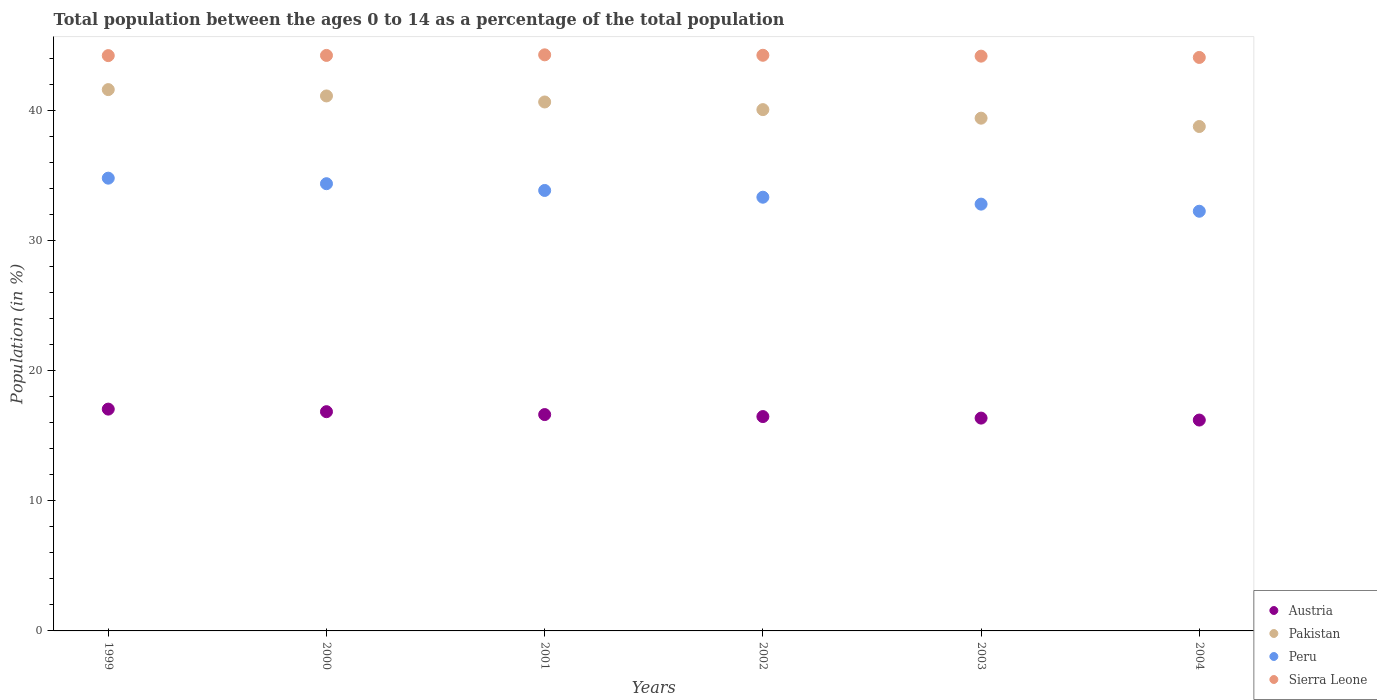Is the number of dotlines equal to the number of legend labels?
Provide a succinct answer. Yes. What is the percentage of the population ages 0 to 14 in Sierra Leone in 2001?
Provide a succinct answer. 44.25. Across all years, what is the maximum percentage of the population ages 0 to 14 in Pakistan?
Your answer should be compact. 41.58. Across all years, what is the minimum percentage of the population ages 0 to 14 in Sierra Leone?
Your response must be concise. 44.05. In which year was the percentage of the population ages 0 to 14 in Austria maximum?
Your answer should be compact. 1999. In which year was the percentage of the population ages 0 to 14 in Austria minimum?
Make the answer very short. 2004. What is the total percentage of the population ages 0 to 14 in Austria in the graph?
Your answer should be very brief. 99.51. What is the difference between the percentage of the population ages 0 to 14 in Austria in 2002 and that in 2004?
Your answer should be compact. 0.27. What is the difference between the percentage of the population ages 0 to 14 in Austria in 2002 and the percentage of the population ages 0 to 14 in Sierra Leone in 2001?
Your response must be concise. -27.79. What is the average percentage of the population ages 0 to 14 in Austria per year?
Provide a short and direct response. 16.59. In the year 1999, what is the difference between the percentage of the population ages 0 to 14 in Austria and percentage of the population ages 0 to 14 in Sierra Leone?
Ensure brevity in your answer.  -27.16. In how many years, is the percentage of the population ages 0 to 14 in Peru greater than 30?
Your response must be concise. 6. What is the ratio of the percentage of the population ages 0 to 14 in Austria in 2001 to that in 2003?
Provide a short and direct response. 1.02. What is the difference between the highest and the second highest percentage of the population ages 0 to 14 in Sierra Leone?
Ensure brevity in your answer.  0.03. What is the difference between the highest and the lowest percentage of the population ages 0 to 14 in Peru?
Offer a very short reply. 2.54. In how many years, is the percentage of the population ages 0 to 14 in Pakistan greater than the average percentage of the population ages 0 to 14 in Pakistan taken over all years?
Offer a very short reply. 3. Is the sum of the percentage of the population ages 0 to 14 in Pakistan in 2000 and 2004 greater than the maximum percentage of the population ages 0 to 14 in Peru across all years?
Provide a succinct answer. Yes. Is it the case that in every year, the sum of the percentage of the population ages 0 to 14 in Sierra Leone and percentage of the population ages 0 to 14 in Pakistan  is greater than the sum of percentage of the population ages 0 to 14 in Austria and percentage of the population ages 0 to 14 in Peru?
Provide a succinct answer. No. Does the percentage of the population ages 0 to 14 in Sierra Leone monotonically increase over the years?
Make the answer very short. No. Is the percentage of the population ages 0 to 14 in Sierra Leone strictly greater than the percentage of the population ages 0 to 14 in Austria over the years?
Keep it short and to the point. Yes. What is the difference between two consecutive major ticks on the Y-axis?
Provide a short and direct response. 10. Does the graph contain grids?
Keep it short and to the point. No. Where does the legend appear in the graph?
Offer a very short reply. Bottom right. How many legend labels are there?
Your response must be concise. 4. What is the title of the graph?
Your answer should be very brief. Total population between the ages 0 to 14 as a percentage of the total population. Does "Saudi Arabia" appear as one of the legend labels in the graph?
Offer a very short reply. No. What is the label or title of the X-axis?
Offer a very short reply. Years. What is the label or title of the Y-axis?
Provide a short and direct response. Population (in %). What is the Population (in %) in Austria in 1999?
Make the answer very short. 17.04. What is the Population (in %) of Pakistan in 1999?
Offer a terse response. 41.58. What is the Population (in %) of Peru in 1999?
Your answer should be very brief. 34.78. What is the Population (in %) of Sierra Leone in 1999?
Ensure brevity in your answer.  44.19. What is the Population (in %) of Austria in 2000?
Your answer should be compact. 16.84. What is the Population (in %) of Pakistan in 2000?
Your answer should be very brief. 41.1. What is the Population (in %) in Peru in 2000?
Offer a terse response. 34.35. What is the Population (in %) in Sierra Leone in 2000?
Offer a terse response. 44.21. What is the Population (in %) of Austria in 2001?
Offer a terse response. 16.62. What is the Population (in %) in Pakistan in 2001?
Your answer should be compact. 40.63. What is the Population (in %) in Peru in 2001?
Provide a short and direct response. 33.84. What is the Population (in %) in Sierra Leone in 2001?
Give a very brief answer. 44.25. What is the Population (in %) in Austria in 2002?
Give a very brief answer. 16.47. What is the Population (in %) in Pakistan in 2002?
Offer a terse response. 40.05. What is the Population (in %) of Peru in 2002?
Your answer should be very brief. 33.32. What is the Population (in %) in Sierra Leone in 2002?
Your answer should be compact. 44.22. What is the Population (in %) in Austria in 2003?
Keep it short and to the point. 16.35. What is the Population (in %) in Pakistan in 2003?
Your answer should be very brief. 39.39. What is the Population (in %) of Peru in 2003?
Keep it short and to the point. 32.79. What is the Population (in %) in Sierra Leone in 2003?
Give a very brief answer. 44.15. What is the Population (in %) of Austria in 2004?
Give a very brief answer. 16.2. What is the Population (in %) of Pakistan in 2004?
Give a very brief answer. 38.75. What is the Population (in %) in Peru in 2004?
Provide a short and direct response. 32.24. What is the Population (in %) in Sierra Leone in 2004?
Make the answer very short. 44.05. Across all years, what is the maximum Population (in %) of Austria?
Ensure brevity in your answer.  17.04. Across all years, what is the maximum Population (in %) of Pakistan?
Provide a succinct answer. 41.58. Across all years, what is the maximum Population (in %) of Peru?
Your answer should be compact. 34.78. Across all years, what is the maximum Population (in %) in Sierra Leone?
Make the answer very short. 44.25. Across all years, what is the minimum Population (in %) of Austria?
Provide a short and direct response. 16.2. Across all years, what is the minimum Population (in %) in Pakistan?
Your answer should be compact. 38.75. Across all years, what is the minimum Population (in %) of Peru?
Provide a succinct answer. 32.24. Across all years, what is the minimum Population (in %) in Sierra Leone?
Keep it short and to the point. 44.05. What is the total Population (in %) of Austria in the graph?
Make the answer very short. 99.51. What is the total Population (in %) in Pakistan in the graph?
Your answer should be very brief. 241.5. What is the total Population (in %) in Peru in the graph?
Keep it short and to the point. 201.31. What is the total Population (in %) in Sierra Leone in the graph?
Keep it short and to the point. 265.09. What is the difference between the Population (in %) in Austria in 1999 and that in 2000?
Provide a succinct answer. 0.2. What is the difference between the Population (in %) of Pakistan in 1999 and that in 2000?
Give a very brief answer. 0.49. What is the difference between the Population (in %) of Peru in 1999 and that in 2000?
Your answer should be compact. 0.43. What is the difference between the Population (in %) of Sierra Leone in 1999 and that in 2000?
Offer a very short reply. -0.01. What is the difference between the Population (in %) in Austria in 1999 and that in 2001?
Offer a terse response. 0.42. What is the difference between the Population (in %) of Pakistan in 1999 and that in 2001?
Offer a very short reply. 0.95. What is the difference between the Population (in %) of Peru in 1999 and that in 2001?
Ensure brevity in your answer.  0.94. What is the difference between the Population (in %) in Sierra Leone in 1999 and that in 2001?
Give a very brief answer. -0.06. What is the difference between the Population (in %) of Austria in 1999 and that in 2002?
Keep it short and to the point. 0.57. What is the difference between the Population (in %) in Pakistan in 1999 and that in 2002?
Ensure brevity in your answer.  1.54. What is the difference between the Population (in %) of Peru in 1999 and that in 2002?
Your answer should be very brief. 1.46. What is the difference between the Population (in %) of Sierra Leone in 1999 and that in 2002?
Provide a succinct answer. -0.03. What is the difference between the Population (in %) in Austria in 1999 and that in 2003?
Make the answer very short. 0.69. What is the difference between the Population (in %) of Pakistan in 1999 and that in 2003?
Provide a succinct answer. 2.19. What is the difference between the Population (in %) in Peru in 1999 and that in 2003?
Ensure brevity in your answer.  1.99. What is the difference between the Population (in %) in Sierra Leone in 1999 and that in 2003?
Your answer should be compact. 0.04. What is the difference between the Population (in %) in Austria in 1999 and that in 2004?
Make the answer very short. 0.84. What is the difference between the Population (in %) of Pakistan in 1999 and that in 2004?
Your answer should be compact. 2.83. What is the difference between the Population (in %) in Peru in 1999 and that in 2004?
Ensure brevity in your answer.  2.54. What is the difference between the Population (in %) in Sierra Leone in 1999 and that in 2004?
Ensure brevity in your answer.  0.14. What is the difference between the Population (in %) of Austria in 2000 and that in 2001?
Offer a terse response. 0.22. What is the difference between the Population (in %) of Pakistan in 2000 and that in 2001?
Ensure brevity in your answer.  0.46. What is the difference between the Population (in %) in Peru in 2000 and that in 2001?
Keep it short and to the point. 0.52. What is the difference between the Population (in %) of Sierra Leone in 2000 and that in 2001?
Your response must be concise. -0.04. What is the difference between the Population (in %) in Austria in 2000 and that in 2002?
Offer a terse response. 0.38. What is the difference between the Population (in %) of Pakistan in 2000 and that in 2002?
Your answer should be compact. 1.05. What is the difference between the Population (in %) in Peru in 2000 and that in 2002?
Ensure brevity in your answer.  1.04. What is the difference between the Population (in %) in Sierra Leone in 2000 and that in 2002?
Your response must be concise. -0.01. What is the difference between the Population (in %) in Austria in 2000 and that in 2003?
Ensure brevity in your answer.  0.49. What is the difference between the Population (in %) in Pakistan in 2000 and that in 2003?
Ensure brevity in your answer.  1.71. What is the difference between the Population (in %) in Peru in 2000 and that in 2003?
Offer a terse response. 1.57. What is the difference between the Population (in %) in Sierra Leone in 2000 and that in 2003?
Provide a short and direct response. 0.06. What is the difference between the Population (in %) of Austria in 2000 and that in 2004?
Give a very brief answer. 0.64. What is the difference between the Population (in %) of Pakistan in 2000 and that in 2004?
Offer a very short reply. 2.35. What is the difference between the Population (in %) of Peru in 2000 and that in 2004?
Your answer should be compact. 2.12. What is the difference between the Population (in %) of Sierra Leone in 2000 and that in 2004?
Provide a short and direct response. 0.16. What is the difference between the Population (in %) of Austria in 2001 and that in 2002?
Offer a terse response. 0.15. What is the difference between the Population (in %) in Pakistan in 2001 and that in 2002?
Your answer should be compact. 0.59. What is the difference between the Population (in %) in Peru in 2001 and that in 2002?
Make the answer very short. 0.52. What is the difference between the Population (in %) of Sierra Leone in 2001 and that in 2002?
Your answer should be very brief. 0.03. What is the difference between the Population (in %) of Austria in 2001 and that in 2003?
Ensure brevity in your answer.  0.27. What is the difference between the Population (in %) of Pakistan in 2001 and that in 2003?
Provide a short and direct response. 1.24. What is the difference between the Population (in %) of Peru in 2001 and that in 2003?
Provide a succinct answer. 1.05. What is the difference between the Population (in %) in Sierra Leone in 2001 and that in 2003?
Make the answer very short. 0.1. What is the difference between the Population (in %) in Austria in 2001 and that in 2004?
Offer a terse response. 0.42. What is the difference between the Population (in %) in Pakistan in 2001 and that in 2004?
Provide a succinct answer. 1.88. What is the difference between the Population (in %) in Peru in 2001 and that in 2004?
Offer a very short reply. 1.6. What is the difference between the Population (in %) of Sierra Leone in 2001 and that in 2004?
Give a very brief answer. 0.2. What is the difference between the Population (in %) in Austria in 2002 and that in 2003?
Provide a short and direct response. 0.12. What is the difference between the Population (in %) of Pakistan in 2002 and that in 2003?
Offer a very short reply. 0.66. What is the difference between the Population (in %) in Peru in 2002 and that in 2003?
Make the answer very short. 0.53. What is the difference between the Population (in %) in Sierra Leone in 2002 and that in 2003?
Keep it short and to the point. 0.07. What is the difference between the Population (in %) in Austria in 2002 and that in 2004?
Your response must be concise. 0.27. What is the difference between the Population (in %) of Pakistan in 2002 and that in 2004?
Offer a terse response. 1.3. What is the difference between the Population (in %) of Peru in 2002 and that in 2004?
Give a very brief answer. 1.08. What is the difference between the Population (in %) in Sierra Leone in 2002 and that in 2004?
Make the answer very short. 0.17. What is the difference between the Population (in %) of Austria in 2003 and that in 2004?
Your response must be concise. 0.15. What is the difference between the Population (in %) of Pakistan in 2003 and that in 2004?
Ensure brevity in your answer.  0.64. What is the difference between the Population (in %) of Peru in 2003 and that in 2004?
Offer a very short reply. 0.55. What is the difference between the Population (in %) of Sierra Leone in 2003 and that in 2004?
Offer a very short reply. 0.1. What is the difference between the Population (in %) in Austria in 1999 and the Population (in %) in Pakistan in 2000?
Your response must be concise. -24.06. What is the difference between the Population (in %) of Austria in 1999 and the Population (in %) of Peru in 2000?
Your response must be concise. -17.32. What is the difference between the Population (in %) of Austria in 1999 and the Population (in %) of Sierra Leone in 2000?
Keep it short and to the point. -27.17. What is the difference between the Population (in %) of Pakistan in 1999 and the Population (in %) of Peru in 2000?
Give a very brief answer. 7.23. What is the difference between the Population (in %) in Pakistan in 1999 and the Population (in %) in Sierra Leone in 2000?
Provide a succinct answer. -2.63. What is the difference between the Population (in %) of Peru in 1999 and the Population (in %) of Sierra Leone in 2000?
Keep it short and to the point. -9.43. What is the difference between the Population (in %) of Austria in 1999 and the Population (in %) of Pakistan in 2001?
Your response must be concise. -23.59. What is the difference between the Population (in %) of Austria in 1999 and the Population (in %) of Peru in 2001?
Offer a very short reply. -16.8. What is the difference between the Population (in %) in Austria in 1999 and the Population (in %) in Sierra Leone in 2001?
Your response must be concise. -27.22. What is the difference between the Population (in %) in Pakistan in 1999 and the Population (in %) in Peru in 2001?
Give a very brief answer. 7.75. What is the difference between the Population (in %) of Pakistan in 1999 and the Population (in %) of Sierra Leone in 2001?
Offer a very short reply. -2.67. What is the difference between the Population (in %) of Peru in 1999 and the Population (in %) of Sierra Leone in 2001?
Provide a succinct answer. -9.47. What is the difference between the Population (in %) in Austria in 1999 and the Population (in %) in Pakistan in 2002?
Keep it short and to the point. -23.01. What is the difference between the Population (in %) of Austria in 1999 and the Population (in %) of Peru in 2002?
Offer a terse response. -16.28. What is the difference between the Population (in %) in Austria in 1999 and the Population (in %) in Sierra Leone in 2002?
Ensure brevity in your answer.  -27.18. What is the difference between the Population (in %) of Pakistan in 1999 and the Population (in %) of Peru in 2002?
Your answer should be very brief. 8.27. What is the difference between the Population (in %) in Pakistan in 1999 and the Population (in %) in Sierra Leone in 2002?
Offer a very short reply. -2.64. What is the difference between the Population (in %) in Peru in 1999 and the Population (in %) in Sierra Leone in 2002?
Offer a terse response. -9.44. What is the difference between the Population (in %) of Austria in 1999 and the Population (in %) of Pakistan in 2003?
Offer a very short reply. -22.35. What is the difference between the Population (in %) in Austria in 1999 and the Population (in %) in Peru in 2003?
Your response must be concise. -15.75. What is the difference between the Population (in %) of Austria in 1999 and the Population (in %) of Sierra Leone in 2003?
Provide a succinct answer. -27.11. What is the difference between the Population (in %) in Pakistan in 1999 and the Population (in %) in Peru in 2003?
Ensure brevity in your answer.  8.8. What is the difference between the Population (in %) of Pakistan in 1999 and the Population (in %) of Sierra Leone in 2003?
Provide a short and direct response. -2.57. What is the difference between the Population (in %) in Peru in 1999 and the Population (in %) in Sierra Leone in 2003?
Provide a short and direct response. -9.37. What is the difference between the Population (in %) in Austria in 1999 and the Population (in %) in Pakistan in 2004?
Offer a terse response. -21.71. What is the difference between the Population (in %) of Austria in 1999 and the Population (in %) of Peru in 2004?
Offer a terse response. -15.2. What is the difference between the Population (in %) in Austria in 1999 and the Population (in %) in Sierra Leone in 2004?
Ensure brevity in your answer.  -27.01. What is the difference between the Population (in %) in Pakistan in 1999 and the Population (in %) in Peru in 2004?
Give a very brief answer. 9.34. What is the difference between the Population (in %) in Pakistan in 1999 and the Population (in %) in Sierra Leone in 2004?
Provide a short and direct response. -2.47. What is the difference between the Population (in %) in Peru in 1999 and the Population (in %) in Sierra Leone in 2004?
Offer a very short reply. -9.27. What is the difference between the Population (in %) in Austria in 2000 and the Population (in %) in Pakistan in 2001?
Offer a terse response. -23.79. What is the difference between the Population (in %) of Austria in 2000 and the Population (in %) of Peru in 2001?
Offer a very short reply. -16.99. What is the difference between the Population (in %) in Austria in 2000 and the Population (in %) in Sierra Leone in 2001?
Provide a short and direct response. -27.41. What is the difference between the Population (in %) in Pakistan in 2000 and the Population (in %) in Peru in 2001?
Make the answer very short. 7.26. What is the difference between the Population (in %) in Pakistan in 2000 and the Population (in %) in Sierra Leone in 2001?
Offer a very short reply. -3.16. What is the difference between the Population (in %) in Peru in 2000 and the Population (in %) in Sierra Leone in 2001?
Offer a terse response. -9.9. What is the difference between the Population (in %) of Austria in 2000 and the Population (in %) of Pakistan in 2002?
Your answer should be compact. -23.2. What is the difference between the Population (in %) in Austria in 2000 and the Population (in %) in Peru in 2002?
Offer a very short reply. -16.48. What is the difference between the Population (in %) in Austria in 2000 and the Population (in %) in Sierra Leone in 2002?
Provide a succinct answer. -27.38. What is the difference between the Population (in %) in Pakistan in 2000 and the Population (in %) in Peru in 2002?
Your answer should be compact. 7.78. What is the difference between the Population (in %) of Pakistan in 2000 and the Population (in %) of Sierra Leone in 2002?
Provide a succinct answer. -3.12. What is the difference between the Population (in %) in Peru in 2000 and the Population (in %) in Sierra Leone in 2002?
Give a very brief answer. -9.87. What is the difference between the Population (in %) of Austria in 2000 and the Population (in %) of Pakistan in 2003?
Give a very brief answer. -22.55. What is the difference between the Population (in %) of Austria in 2000 and the Population (in %) of Peru in 2003?
Offer a very short reply. -15.94. What is the difference between the Population (in %) in Austria in 2000 and the Population (in %) in Sierra Leone in 2003?
Your answer should be very brief. -27.31. What is the difference between the Population (in %) in Pakistan in 2000 and the Population (in %) in Peru in 2003?
Offer a very short reply. 8.31. What is the difference between the Population (in %) of Pakistan in 2000 and the Population (in %) of Sierra Leone in 2003?
Your answer should be very brief. -3.06. What is the difference between the Population (in %) in Peru in 2000 and the Population (in %) in Sierra Leone in 2003?
Your response must be concise. -9.8. What is the difference between the Population (in %) in Austria in 2000 and the Population (in %) in Pakistan in 2004?
Keep it short and to the point. -21.91. What is the difference between the Population (in %) in Austria in 2000 and the Population (in %) in Peru in 2004?
Your response must be concise. -15.4. What is the difference between the Population (in %) of Austria in 2000 and the Population (in %) of Sierra Leone in 2004?
Provide a succinct answer. -27.21. What is the difference between the Population (in %) of Pakistan in 2000 and the Population (in %) of Peru in 2004?
Give a very brief answer. 8.86. What is the difference between the Population (in %) in Pakistan in 2000 and the Population (in %) in Sierra Leone in 2004?
Provide a succinct answer. -2.96. What is the difference between the Population (in %) of Peru in 2000 and the Population (in %) of Sierra Leone in 2004?
Make the answer very short. -9.7. What is the difference between the Population (in %) in Austria in 2001 and the Population (in %) in Pakistan in 2002?
Offer a terse response. -23.43. What is the difference between the Population (in %) in Austria in 2001 and the Population (in %) in Peru in 2002?
Your response must be concise. -16.7. What is the difference between the Population (in %) of Austria in 2001 and the Population (in %) of Sierra Leone in 2002?
Make the answer very short. -27.6. What is the difference between the Population (in %) in Pakistan in 2001 and the Population (in %) in Peru in 2002?
Provide a short and direct response. 7.32. What is the difference between the Population (in %) in Pakistan in 2001 and the Population (in %) in Sierra Leone in 2002?
Your response must be concise. -3.59. What is the difference between the Population (in %) in Peru in 2001 and the Population (in %) in Sierra Leone in 2002?
Your answer should be compact. -10.38. What is the difference between the Population (in %) of Austria in 2001 and the Population (in %) of Pakistan in 2003?
Ensure brevity in your answer.  -22.77. What is the difference between the Population (in %) in Austria in 2001 and the Population (in %) in Peru in 2003?
Provide a succinct answer. -16.17. What is the difference between the Population (in %) in Austria in 2001 and the Population (in %) in Sierra Leone in 2003?
Your answer should be very brief. -27.53. What is the difference between the Population (in %) in Pakistan in 2001 and the Population (in %) in Peru in 2003?
Provide a succinct answer. 7.85. What is the difference between the Population (in %) in Pakistan in 2001 and the Population (in %) in Sierra Leone in 2003?
Provide a short and direct response. -3.52. What is the difference between the Population (in %) of Peru in 2001 and the Population (in %) of Sierra Leone in 2003?
Your response must be concise. -10.32. What is the difference between the Population (in %) in Austria in 2001 and the Population (in %) in Pakistan in 2004?
Give a very brief answer. -22.13. What is the difference between the Population (in %) of Austria in 2001 and the Population (in %) of Peru in 2004?
Give a very brief answer. -15.62. What is the difference between the Population (in %) in Austria in 2001 and the Population (in %) in Sierra Leone in 2004?
Ensure brevity in your answer.  -27.43. What is the difference between the Population (in %) of Pakistan in 2001 and the Population (in %) of Peru in 2004?
Give a very brief answer. 8.39. What is the difference between the Population (in %) of Pakistan in 2001 and the Population (in %) of Sierra Leone in 2004?
Offer a terse response. -3.42. What is the difference between the Population (in %) in Peru in 2001 and the Population (in %) in Sierra Leone in 2004?
Keep it short and to the point. -10.22. What is the difference between the Population (in %) in Austria in 2002 and the Population (in %) in Pakistan in 2003?
Provide a short and direct response. -22.92. What is the difference between the Population (in %) in Austria in 2002 and the Population (in %) in Peru in 2003?
Your answer should be very brief. -16.32. What is the difference between the Population (in %) in Austria in 2002 and the Population (in %) in Sierra Leone in 2003?
Ensure brevity in your answer.  -27.69. What is the difference between the Population (in %) in Pakistan in 2002 and the Population (in %) in Peru in 2003?
Make the answer very short. 7.26. What is the difference between the Population (in %) of Pakistan in 2002 and the Population (in %) of Sierra Leone in 2003?
Your response must be concise. -4.11. What is the difference between the Population (in %) of Peru in 2002 and the Population (in %) of Sierra Leone in 2003?
Ensure brevity in your answer.  -10.84. What is the difference between the Population (in %) in Austria in 2002 and the Population (in %) in Pakistan in 2004?
Your response must be concise. -22.28. What is the difference between the Population (in %) of Austria in 2002 and the Population (in %) of Peru in 2004?
Give a very brief answer. -15.77. What is the difference between the Population (in %) of Austria in 2002 and the Population (in %) of Sierra Leone in 2004?
Keep it short and to the point. -27.59. What is the difference between the Population (in %) in Pakistan in 2002 and the Population (in %) in Peru in 2004?
Your answer should be very brief. 7.81. What is the difference between the Population (in %) of Pakistan in 2002 and the Population (in %) of Sierra Leone in 2004?
Your answer should be very brief. -4.01. What is the difference between the Population (in %) of Peru in 2002 and the Population (in %) of Sierra Leone in 2004?
Your answer should be very brief. -10.74. What is the difference between the Population (in %) in Austria in 2003 and the Population (in %) in Pakistan in 2004?
Your answer should be compact. -22.4. What is the difference between the Population (in %) in Austria in 2003 and the Population (in %) in Peru in 2004?
Offer a terse response. -15.89. What is the difference between the Population (in %) in Austria in 2003 and the Population (in %) in Sierra Leone in 2004?
Your response must be concise. -27.71. What is the difference between the Population (in %) of Pakistan in 2003 and the Population (in %) of Peru in 2004?
Your answer should be compact. 7.15. What is the difference between the Population (in %) in Pakistan in 2003 and the Population (in %) in Sierra Leone in 2004?
Your answer should be very brief. -4.67. What is the difference between the Population (in %) of Peru in 2003 and the Population (in %) of Sierra Leone in 2004?
Your answer should be compact. -11.27. What is the average Population (in %) in Austria per year?
Keep it short and to the point. 16.59. What is the average Population (in %) of Pakistan per year?
Your answer should be compact. 40.25. What is the average Population (in %) in Peru per year?
Provide a short and direct response. 33.55. What is the average Population (in %) in Sierra Leone per year?
Offer a terse response. 44.18. In the year 1999, what is the difference between the Population (in %) of Austria and Population (in %) of Pakistan?
Ensure brevity in your answer.  -24.54. In the year 1999, what is the difference between the Population (in %) in Austria and Population (in %) in Peru?
Offer a very short reply. -17.74. In the year 1999, what is the difference between the Population (in %) in Austria and Population (in %) in Sierra Leone?
Keep it short and to the point. -27.16. In the year 1999, what is the difference between the Population (in %) of Pakistan and Population (in %) of Peru?
Ensure brevity in your answer.  6.8. In the year 1999, what is the difference between the Population (in %) of Pakistan and Population (in %) of Sierra Leone?
Offer a terse response. -2.61. In the year 1999, what is the difference between the Population (in %) in Peru and Population (in %) in Sierra Leone?
Your response must be concise. -9.41. In the year 2000, what is the difference between the Population (in %) of Austria and Population (in %) of Pakistan?
Keep it short and to the point. -24.26. In the year 2000, what is the difference between the Population (in %) in Austria and Population (in %) in Peru?
Make the answer very short. -17.51. In the year 2000, what is the difference between the Population (in %) of Austria and Population (in %) of Sierra Leone?
Your response must be concise. -27.37. In the year 2000, what is the difference between the Population (in %) in Pakistan and Population (in %) in Peru?
Your response must be concise. 6.74. In the year 2000, what is the difference between the Population (in %) in Pakistan and Population (in %) in Sierra Leone?
Give a very brief answer. -3.11. In the year 2000, what is the difference between the Population (in %) of Peru and Population (in %) of Sierra Leone?
Provide a short and direct response. -9.85. In the year 2001, what is the difference between the Population (in %) of Austria and Population (in %) of Pakistan?
Provide a short and direct response. -24.01. In the year 2001, what is the difference between the Population (in %) of Austria and Population (in %) of Peru?
Offer a terse response. -17.22. In the year 2001, what is the difference between the Population (in %) in Austria and Population (in %) in Sierra Leone?
Make the answer very short. -27.63. In the year 2001, what is the difference between the Population (in %) of Pakistan and Population (in %) of Peru?
Your answer should be compact. 6.8. In the year 2001, what is the difference between the Population (in %) in Pakistan and Population (in %) in Sierra Leone?
Give a very brief answer. -3.62. In the year 2001, what is the difference between the Population (in %) in Peru and Population (in %) in Sierra Leone?
Keep it short and to the point. -10.42. In the year 2002, what is the difference between the Population (in %) in Austria and Population (in %) in Pakistan?
Offer a terse response. -23.58. In the year 2002, what is the difference between the Population (in %) in Austria and Population (in %) in Peru?
Make the answer very short. -16.85. In the year 2002, what is the difference between the Population (in %) of Austria and Population (in %) of Sierra Leone?
Offer a very short reply. -27.75. In the year 2002, what is the difference between the Population (in %) of Pakistan and Population (in %) of Peru?
Make the answer very short. 6.73. In the year 2002, what is the difference between the Population (in %) of Pakistan and Population (in %) of Sierra Leone?
Keep it short and to the point. -4.18. In the year 2002, what is the difference between the Population (in %) of Peru and Population (in %) of Sierra Leone?
Your answer should be compact. -10.9. In the year 2003, what is the difference between the Population (in %) in Austria and Population (in %) in Pakistan?
Provide a short and direct response. -23.04. In the year 2003, what is the difference between the Population (in %) in Austria and Population (in %) in Peru?
Your answer should be very brief. -16.44. In the year 2003, what is the difference between the Population (in %) in Austria and Population (in %) in Sierra Leone?
Provide a short and direct response. -27.81. In the year 2003, what is the difference between the Population (in %) of Pakistan and Population (in %) of Peru?
Ensure brevity in your answer.  6.6. In the year 2003, what is the difference between the Population (in %) of Pakistan and Population (in %) of Sierra Leone?
Ensure brevity in your answer.  -4.76. In the year 2003, what is the difference between the Population (in %) of Peru and Population (in %) of Sierra Leone?
Provide a short and direct response. -11.37. In the year 2004, what is the difference between the Population (in %) in Austria and Population (in %) in Pakistan?
Offer a very short reply. -22.55. In the year 2004, what is the difference between the Population (in %) in Austria and Population (in %) in Peru?
Your response must be concise. -16.04. In the year 2004, what is the difference between the Population (in %) in Austria and Population (in %) in Sierra Leone?
Your answer should be compact. -27.86. In the year 2004, what is the difference between the Population (in %) in Pakistan and Population (in %) in Peru?
Give a very brief answer. 6.51. In the year 2004, what is the difference between the Population (in %) in Pakistan and Population (in %) in Sierra Leone?
Offer a terse response. -5.31. In the year 2004, what is the difference between the Population (in %) of Peru and Population (in %) of Sierra Leone?
Provide a short and direct response. -11.81. What is the ratio of the Population (in %) in Austria in 1999 to that in 2000?
Provide a short and direct response. 1.01. What is the ratio of the Population (in %) in Pakistan in 1999 to that in 2000?
Your response must be concise. 1.01. What is the ratio of the Population (in %) in Peru in 1999 to that in 2000?
Offer a terse response. 1.01. What is the ratio of the Population (in %) of Austria in 1999 to that in 2001?
Offer a very short reply. 1.03. What is the ratio of the Population (in %) of Pakistan in 1999 to that in 2001?
Your answer should be compact. 1.02. What is the ratio of the Population (in %) of Peru in 1999 to that in 2001?
Make the answer very short. 1.03. What is the ratio of the Population (in %) of Sierra Leone in 1999 to that in 2001?
Make the answer very short. 1. What is the ratio of the Population (in %) of Austria in 1999 to that in 2002?
Offer a terse response. 1.03. What is the ratio of the Population (in %) in Pakistan in 1999 to that in 2002?
Ensure brevity in your answer.  1.04. What is the ratio of the Population (in %) in Peru in 1999 to that in 2002?
Provide a short and direct response. 1.04. What is the ratio of the Population (in %) of Sierra Leone in 1999 to that in 2002?
Your answer should be very brief. 1. What is the ratio of the Population (in %) of Austria in 1999 to that in 2003?
Your response must be concise. 1.04. What is the ratio of the Population (in %) in Pakistan in 1999 to that in 2003?
Your response must be concise. 1.06. What is the ratio of the Population (in %) in Peru in 1999 to that in 2003?
Your answer should be compact. 1.06. What is the ratio of the Population (in %) in Austria in 1999 to that in 2004?
Ensure brevity in your answer.  1.05. What is the ratio of the Population (in %) of Pakistan in 1999 to that in 2004?
Your answer should be compact. 1.07. What is the ratio of the Population (in %) of Peru in 1999 to that in 2004?
Offer a very short reply. 1.08. What is the ratio of the Population (in %) in Sierra Leone in 1999 to that in 2004?
Give a very brief answer. 1. What is the ratio of the Population (in %) of Austria in 2000 to that in 2001?
Your answer should be compact. 1.01. What is the ratio of the Population (in %) of Pakistan in 2000 to that in 2001?
Your response must be concise. 1.01. What is the ratio of the Population (in %) of Peru in 2000 to that in 2001?
Offer a terse response. 1.02. What is the ratio of the Population (in %) of Austria in 2000 to that in 2002?
Ensure brevity in your answer.  1.02. What is the ratio of the Population (in %) in Pakistan in 2000 to that in 2002?
Your answer should be compact. 1.03. What is the ratio of the Population (in %) of Peru in 2000 to that in 2002?
Your answer should be compact. 1.03. What is the ratio of the Population (in %) of Sierra Leone in 2000 to that in 2002?
Provide a succinct answer. 1. What is the ratio of the Population (in %) in Austria in 2000 to that in 2003?
Your response must be concise. 1.03. What is the ratio of the Population (in %) of Pakistan in 2000 to that in 2003?
Your answer should be very brief. 1.04. What is the ratio of the Population (in %) of Peru in 2000 to that in 2003?
Your answer should be very brief. 1.05. What is the ratio of the Population (in %) of Austria in 2000 to that in 2004?
Ensure brevity in your answer.  1.04. What is the ratio of the Population (in %) of Pakistan in 2000 to that in 2004?
Provide a succinct answer. 1.06. What is the ratio of the Population (in %) in Peru in 2000 to that in 2004?
Keep it short and to the point. 1.07. What is the ratio of the Population (in %) in Sierra Leone in 2000 to that in 2004?
Ensure brevity in your answer.  1. What is the ratio of the Population (in %) in Austria in 2001 to that in 2002?
Make the answer very short. 1.01. What is the ratio of the Population (in %) of Pakistan in 2001 to that in 2002?
Keep it short and to the point. 1.01. What is the ratio of the Population (in %) of Peru in 2001 to that in 2002?
Give a very brief answer. 1.02. What is the ratio of the Population (in %) in Sierra Leone in 2001 to that in 2002?
Keep it short and to the point. 1. What is the ratio of the Population (in %) in Austria in 2001 to that in 2003?
Give a very brief answer. 1.02. What is the ratio of the Population (in %) of Pakistan in 2001 to that in 2003?
Provide a short and direct response. 1.03. What is the ratio of the Population (in %) of Peru in 2001 to that in 2003?
Provide a short and direct response. 1.03. What is the ratio of the Population (in %) of Sierra Leone in 2001 to that in 2003?
Your response must be concise. 1. What is the ratio of the Population (in %) in Pakistan in 2001 to that in 2004?
Ensure brevity in your answer.  1.05. What is the ratio of the Population (in %) in Peru in 2001 to that in 2004?
Your answer should be very brief. 1.05. What is the ratio of the Population (in %) in Pakistan in 2002 to that in 2003?
Provide a succinct answer. 1.02. What is the ratio of the Population (in %) of Peru in 2002 to that in 2003?
Offer a very short reply. 1.02. What is the ratio of the Population (in %) in Austria in 2002 to that in 2004?
Your answer should be compact. 1.02. What is the ratio of the Population (in %) in Pakistan in 2002 to that in 2004?
Your answer should be very brief. 1.03. What is the ratio of the Population (in %) in Peru in 2002 to that in 2004?
Offer a terse response. 1.03. What is the ratio of the Population (in %) of Austria in 2003 to that in 2004?
Your answer should be compact. 1.01. What is the ratio of the Population (in %) of Pakistan in 2003 to that in 2004?
Your answer should be very brief. 1.02. What is the ratio of the Population (in %) in Peru in 2003 to that in 2004?
Your response must be concise. 1.02. What is the ratio of the Population (in %) of Sierra Leone in 2003 to that in 2004?
Your response must be concise. 1. What is the difference between the highest and the second highest Population (in %) of Austria?
Provide a short and direct response. 0.2. What is the difference between the highest and the second highest Population (in %) in Pakistan?
Offer a terse response. 0.49. What is the difference between the highest and the second highest Population (in %) in Peru?
Offer a terse response. 0.43. What is the difference between the highest and the second highest Population (in %) in Sierra Leone?
Your response must be concise. 0.03. What is the difference between the highest and the lowest Population (in %) in Austria?
Ensure brevity in your answer.  0.84. What is the difference between the highest and the lowest Population (in %) of Pakistan?
Ensure brevity in your answer.  2.83. What is the difference between the highest and the lowest Population (in %) in Peru?
Your answer should be compact. 2.54. What is the difference between the highest and the lowest Population (in %) in Sierra Leone?
Offer a very short reply. 0.2. 